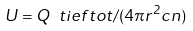Convert formula to latex. <formula><loc_0><loc_0><loc_500><loc_500>U = Q \ t i e f { t o t } / ( 4 \pi { r } ^ { 2 } c n )</formula> 